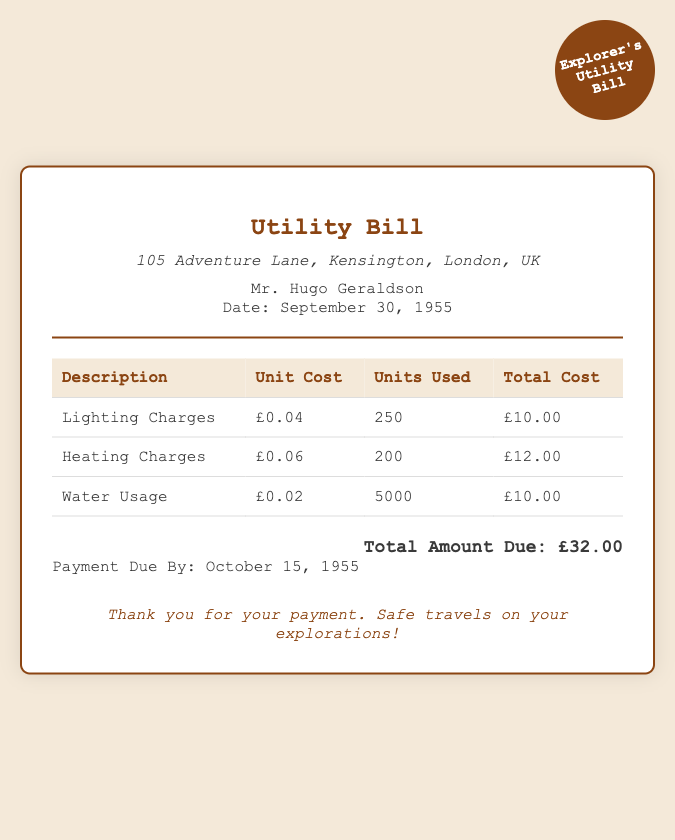what is the total amount due? The total amount due is clearly stated in the document and is found at the bottom of the bill.
Answer: £32.00 what address is listed on the bill? The address listed on the bill is provided in the header section, indicating where the charges apply.
Answer: 105 Adventure Lane, Kensington, London, UK who is the bill addressed to? The document specifies the individual to whom the bill is addressed by name in the header section.
Answer: Mr. Hugo Geraldson what is the date of the bill? The date of the bill is mentioned in the header, indicating when the bill was issued.
Answer: September 30, 1955 how many units of water usage are charged? The number of water usage units is specified in one of the line items in the table.
Answer: 5000 what is the unit cost for heating charges? The unit cost for heating is detailed in the table for heating charges, showing the price per unit.
Answer: £0.06 when is the payment due by? The due date for payment is mentioned toward the bottom of the document as a specific date.
Answer: October 15, 1955 how much was paid for lighting charges? The total cost for lighting is listed in the table, representing the total amount charged for that service.
Answer: £10.00 how many units were used for lighting? The document provides the number of lighting units consumed, which is stated in the itemized bill.
Answer: 250 